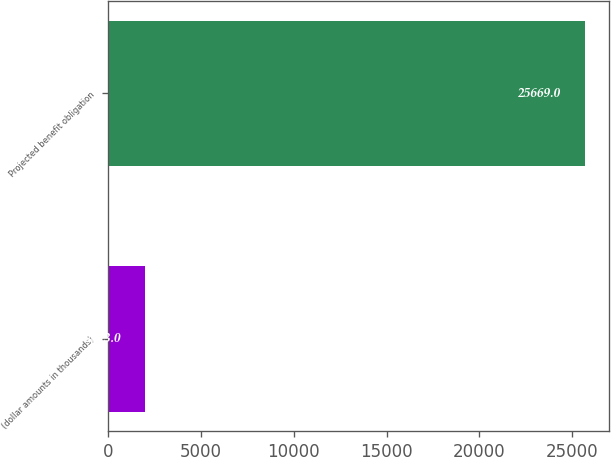Convert chart. <chart><loc_0><loc_0><loc_500><loc_500><bar_chart><fcel>(dollar amounts in thousands)<fcel>Projected benefit obligation<nl><fcel>2013<fcel>25669<nl></chart> 